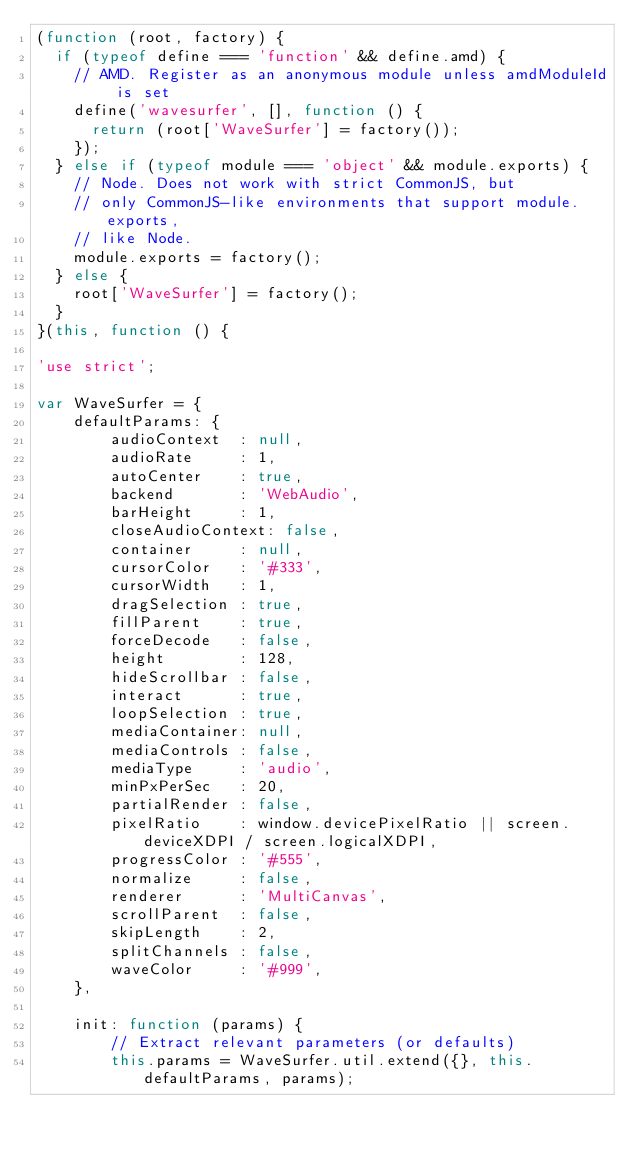Convert code to text. <code><loc_0><loc_0><loc_500><loc_500><_JavaScript_>(function (root, factory) {
  if (typeof define === 'function' && define.amd) {
    // AMD. Register as an anonymous module unless amdModuleId is set
    define('wavesurfer', [], function () {
      return (root['WaveSurfer'] = factory());
    });
  } else if (typeof module === 'object' && module.exports) {
    // Node. Does not work with strict CommonJS, but
    // only CommonJS-like environments that support module.exports,
    // like Node.
    module.exports = factory();
  } else {
    root['WaveSurfer'] = factory();
  }
}(this, function () {

'use strict';

var WaveSurfer = {
    defaultParams: {
        audioContext  : null,
        audioRate     : 1,
        autoCenter    : true,
        backend       : 'WebAudio',
        barHeight     : 1,
        closeAudioContext: false,
        container     : null,
        cursorColor   : '#333',
        cursorWidth   : 1,
        dragSelection : true,
        fillParent    : true,
        forceDecode   : false,
        height        : 128,
        hideScrollbar : false,
        interact      : true,
        loopSelection : true,
        mediaContainer: null,
        mediaControls : false,
        mediaType     : 'audio',
        minPxPerSec   : 20,
        partialRender : false,
        pixelRatio    : window.devicePixelRatio || screen.deviceXDPI / screen.logicalXDPI,
        progressColor : '#555',
        normalize     : false,
        renderer      : 'MultiCanvas',
        scrollParent  : false,
        skipLength    : 2,
        splitChannels : false,
        waveColor     : '#999',
    },

    init: function (params) {
        // Extract relevant parameters (or defaults)
        this.params = WaveSurfer.util.extend({}, this.defaultParams, params);
</code> 